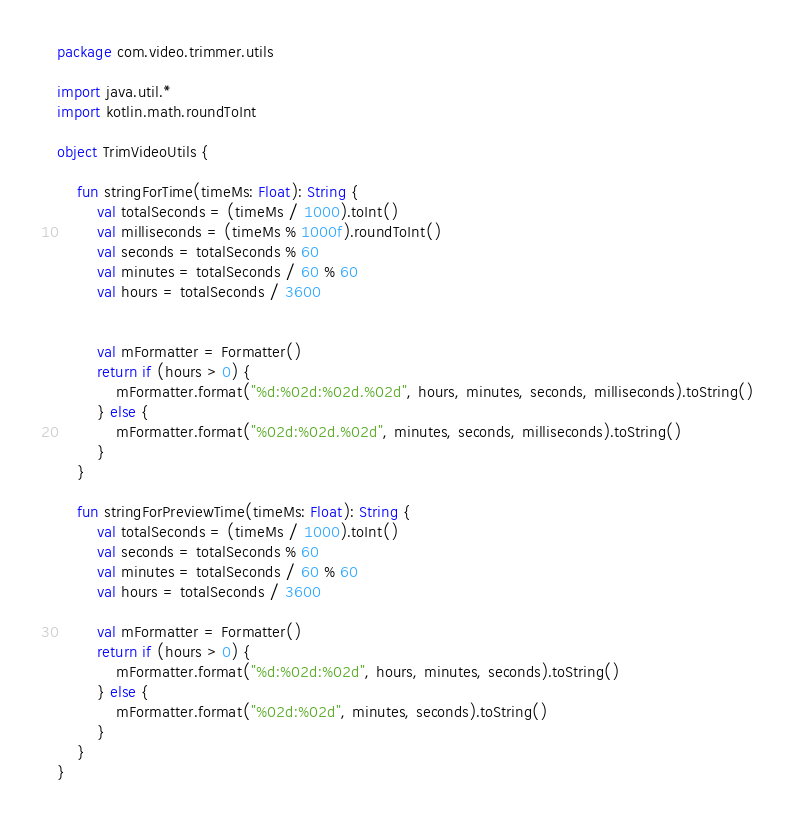Convert code to text. <code><loc_0><loc_0><loc_500><loc_500><_Kotlin_>package com.video.trimmer.utils

import java.util.*
import kotlin.math.roundToInt

object TrimVideoUtils {

    fun stringForTime(timeMs: Float): String {
        val totalSeconds = (timeMs / 1000).toInt()
        val milliseconds = (timeMs % 1000f).roundToInt()
        val seconds = totalSeconds % 60
        val minutes = totalSeconds / 60 % 60
        val hours = totalSeconds / 3600


        val mFormatter = Formatter()
        return if (hours > 0) {
            mFormatter.format("%d:%02d:%02d.%02d", hours, minutes, seconds, milliseconds).toString()
        } else {
            mFormatter.format("%02d:%02d.%02d", minutes, seconds, milliseconds).toString()
        }
    }

    fun stringForPreviewTime(timeMs: Float): String {
        val totalSeconds = (timeMs / 1000).toInt()
        val seconds = totalSeconds % 60
        val minutes = totalSeconds / 60 % 60
        val hours = totalSeconds / 3600

        val mFormatter = Formatter()
        return if (hours > 0) {
            mFormatter.format("%d:%02d:%02d", hours, minutes, seconds).toString()
        } else {
            mFormatter.format("%02d:%02d", minutes, seconds).toString()
        }
    }
}
</code> 